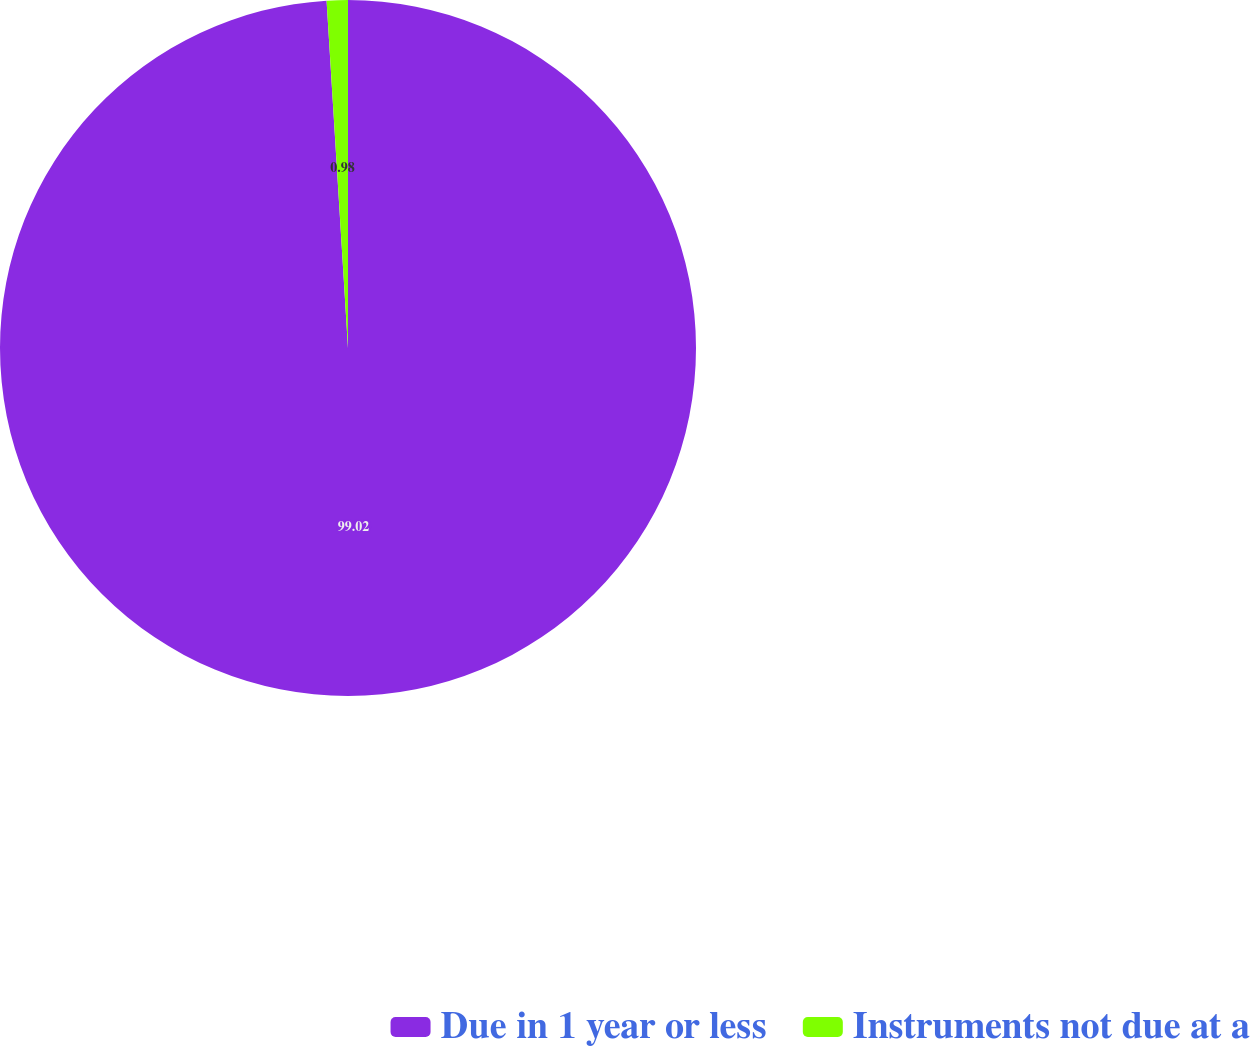<chart> <loc_0><loc_0><loc_500><loc_500><pie_chart><fcel>Due in 1 year or less<fcel>Instruments not due at a<nl><fcel>99.02%<fcel>0.98%<nl></chart> 